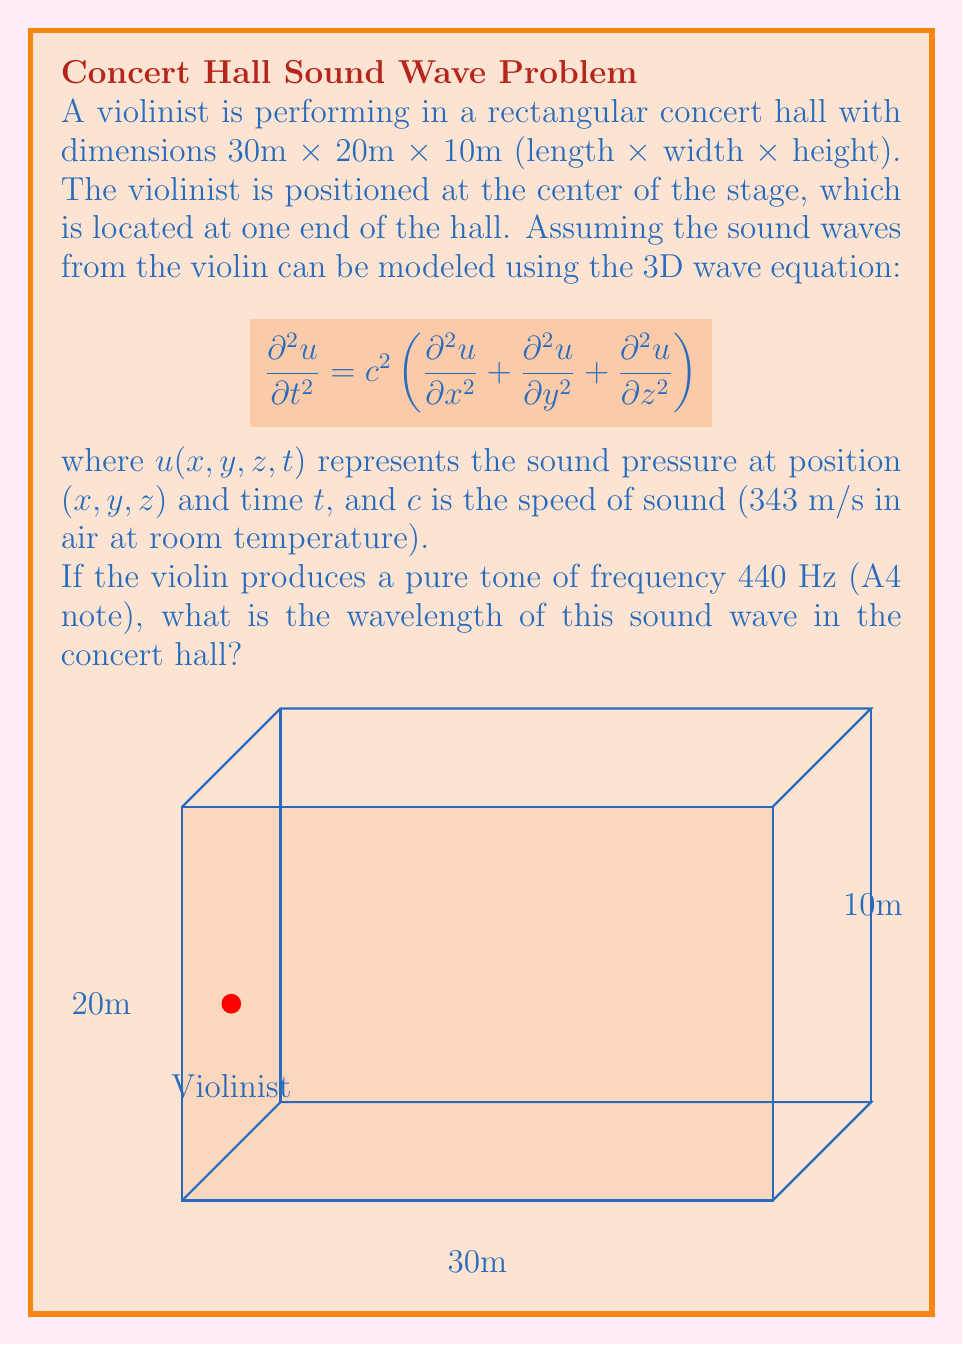Can you answer this question? To solve this problem, we need to use the relationship between wavelength, frequency, and speed of sound. The steps are as follows:

1) The general equation relating wavelength ($\lambda$), frequency ($f$), and wave speed ($c$) is:

   $$c = f\lambda$$

2) We are given the frequency $f = 440$ Hz and the speed of sound $c = 343$ m/s.

3) Rearranging the equation to solve for wavelength:

   $$\lambda = \frac{c}{f}$$

4) Substituting the known values:

   $$\lambda = \frac{343 \text{ m/s}}{440 \text{ Hz}}$$

5) Performing the calculation:

   $$\lambda = 0.77954545... \text{ m}$$

6) Rounding to two decimal places for a reasonable precision:

   $$\lambda \approx 0.78 \text{ m}$$

This wavelength represents the spatial period of the sound wave as it propagates through the concert hall. It's worth noting that while the wave equation describes the propagation of the sound wave, the wavelength itself is independent of the specific dimensions of the hall in this idealized scenario.
Answer: $0.78 \text{ m}$ 